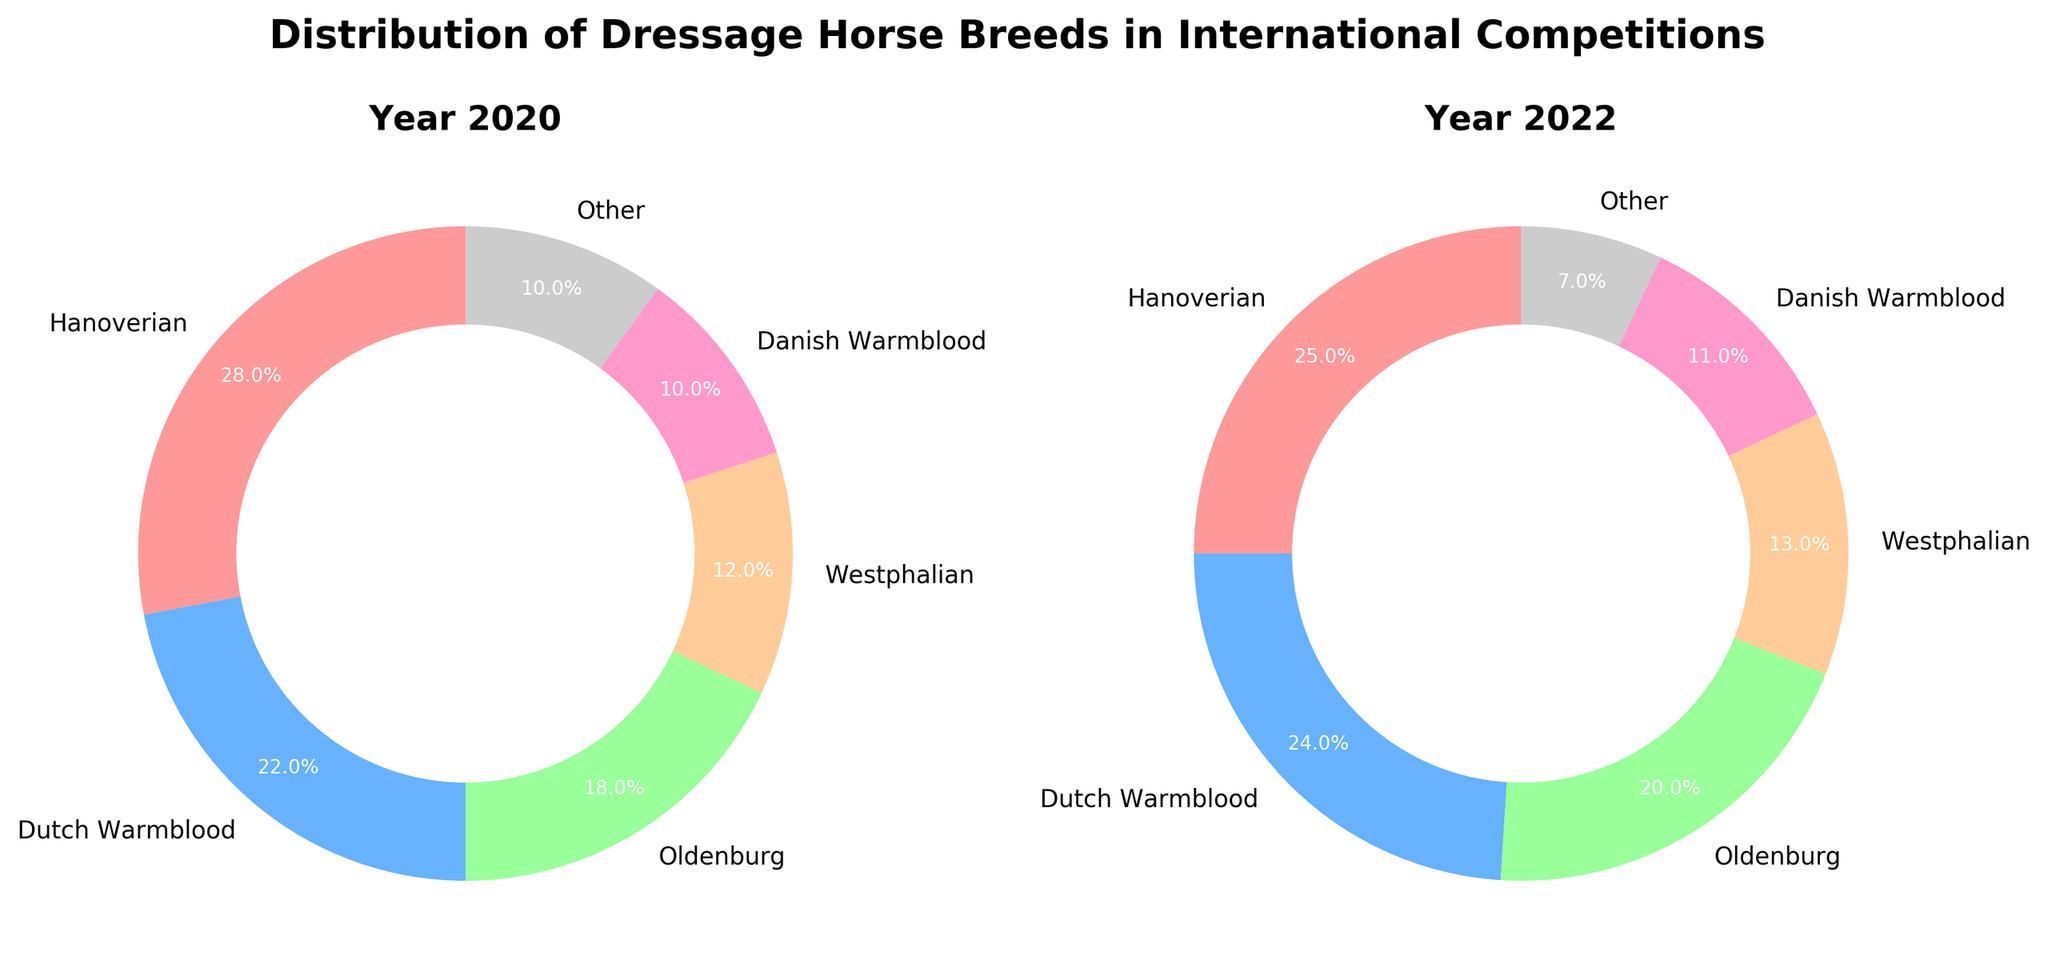What is the title of the figure? The title of the figure can be found at the top center of the figure. It is usually bold and large compared to other texts on the figure.
Answer: Distribution of Dressage Horse Breeds in International Competitions How many breeds are represented in the pie chart for the year 2022? Count the number of distinct labels in the pie chart for the year 2022. Each label corresponds to a different breed.
Answer: 6 Which breed has the highest percentage in 2020 and what is its percentage? Look at the pie chart for 2020 and find the slice with the largest percentage label. The breed name is mentioned next to this slice.
Answer: Hanoverian, 28% What is the combined percentage of Dutch Warmblood and Westphalian in 2022? Identify the percentage slices for Dutch Warmblood and Westphalian in the 2022 pie chart and sum them up.
Answer: 24% + 13% = 37% Which breed shows a decrease in percentage from 2020 to 2022? Compare the percentages of each breed in the 2020 pie chart to their corresponding percentages in the 2022 pie chart. Identify the breed(s) with a lower percentage in 2022 compared to 2020.
Answer: Hanoverian, Oldenburg, Other In which year is the percentage of Danis Warmblood higher and by how much? Compare the percentage of Danish Warmblood in both years. Subtract the percentage of the year with less from the year with more to find the difference.
Answer: 2022, 1% What is the total percentage of breeds classified as 'Other' across both years? Add the percentages of the 'Other' category in the 2020 and 2022 pie charts.
Answer: 10% + 7% = 17% How does the percentage of Oldenburg differ between 2020 and 2022? Subtract the percentage of Oldenburg in 2020 from the percentage in 2022 to find the difference.
Answer: 20% - 18% = 2% increase Which breed had the smallest percentage in 2020 and what was this percentage? Look at the pie chart for 2020 and find the breed with the smallest percentage slice.
Answer: Danish Warmblood and Other, 10% 